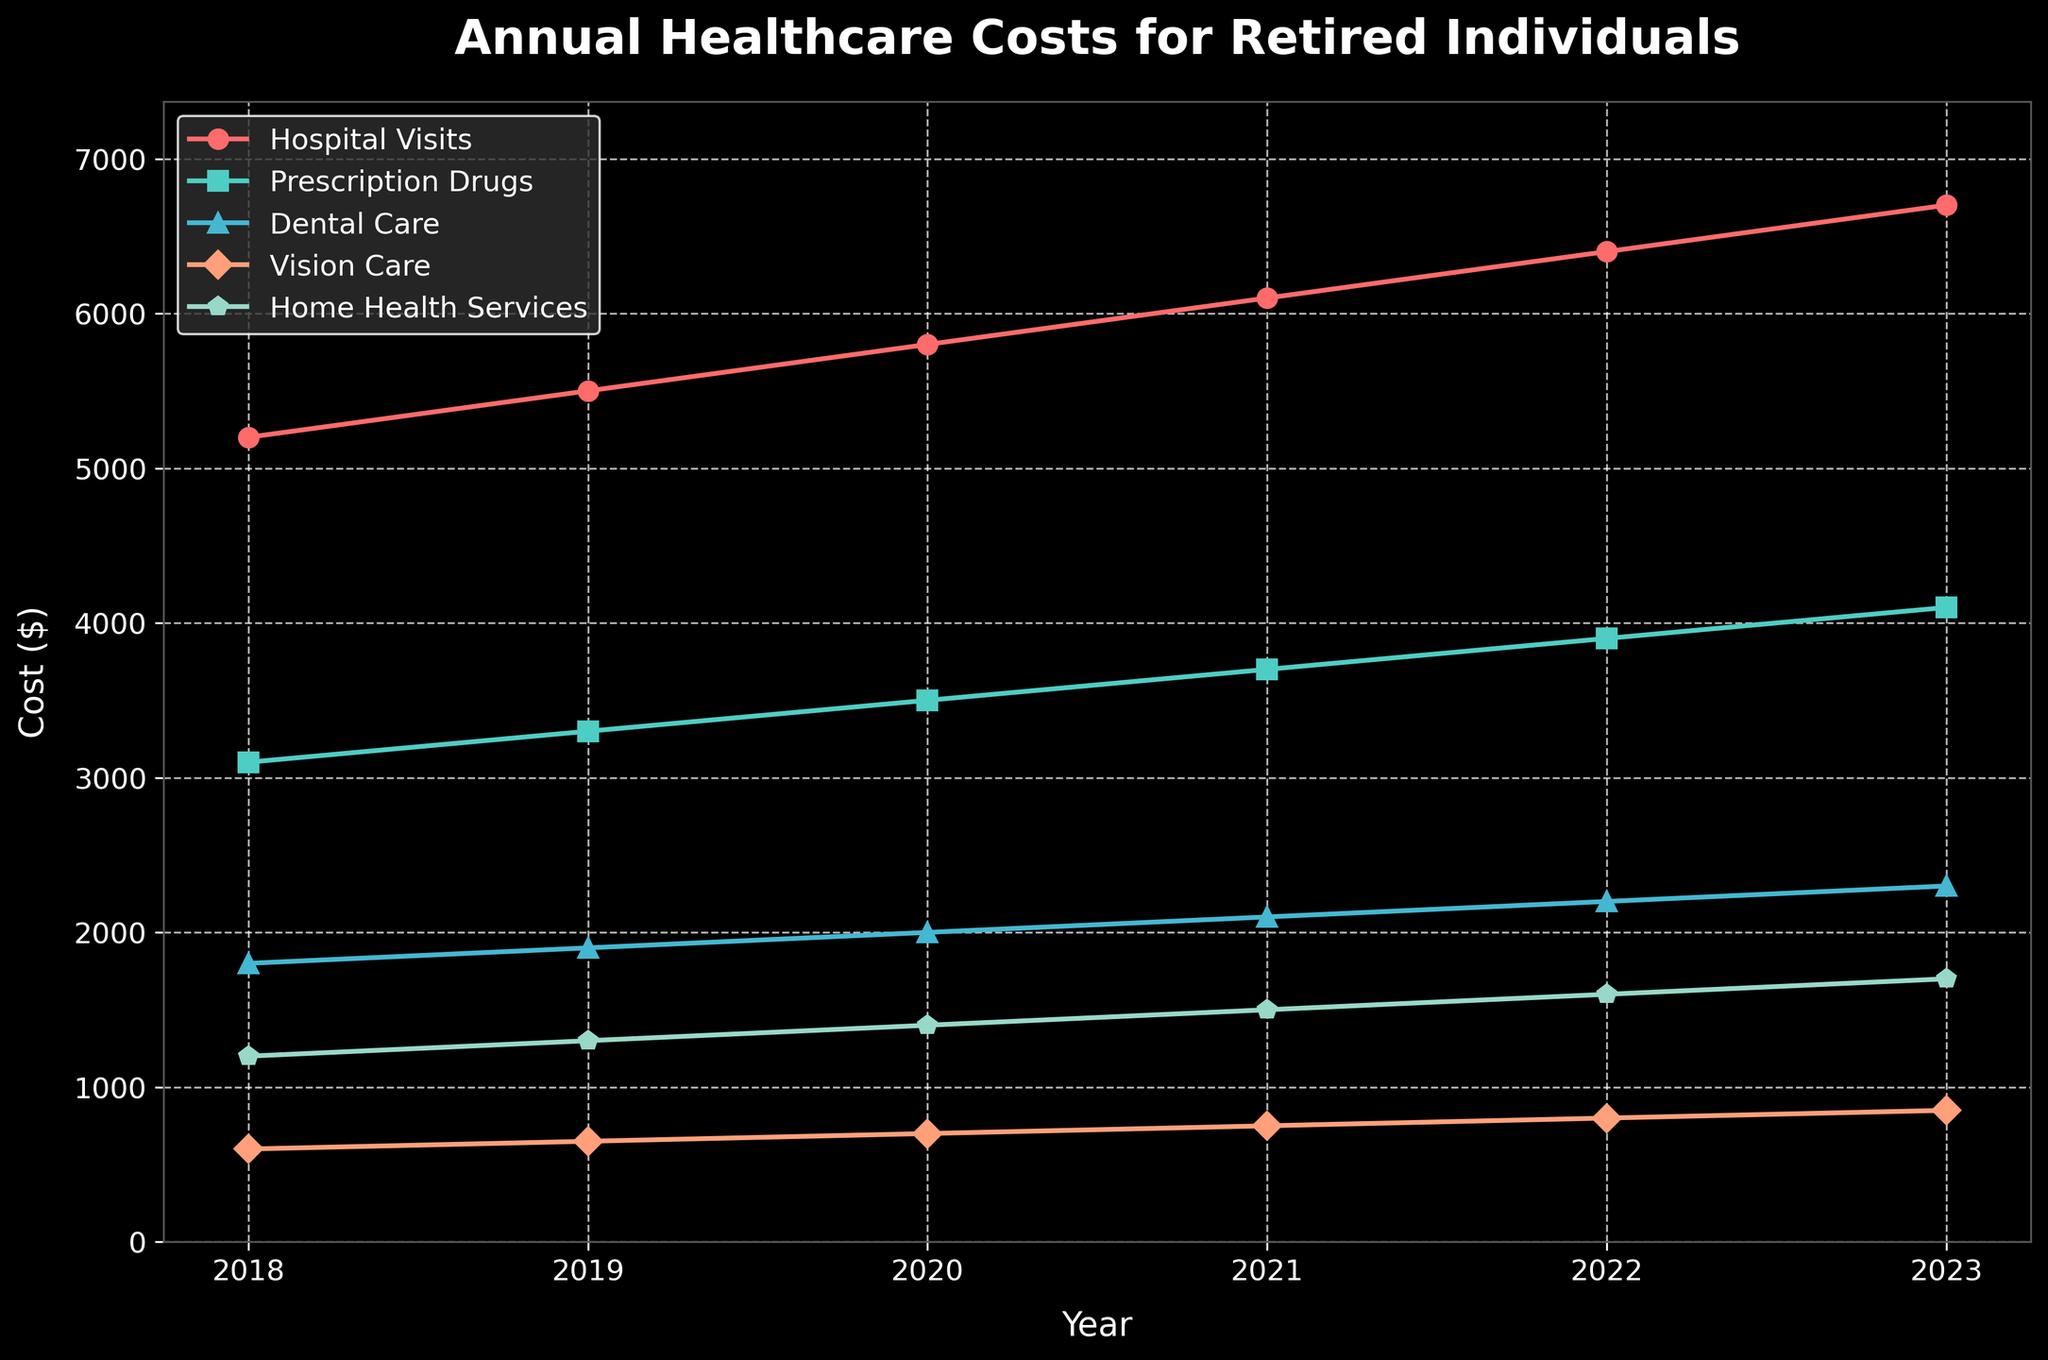What is the cost difference between Hospital Visits in 2023 and 2018? The cost of Hospital Visits in 2023 is $6700, and in 2018 it was $5200. The difference is $6700 - $5200 = $1500.
Answer: $1500 Which year shows the highest cost for Prescription Drugs? By looking at the Prescription Drugs line, the highest value is in 2023, where the cost is $4100.
Answer: 2023 What is the average annual cost of Vision Care from 2018 to 2023? Add the annual costs of Vision Care from 2018 to 2023: 600 + 650 + 700 + 750 + 800 + 850 = 4350. Divide by the number of years: 4350 / 6 = 725.
Answer: $725 Between Dental Care and Home Health Services, which had a higher increase in cost from 2018 to 2023? The increase for Dental Care from 2018 to 2023 is $2300 - $1800 = $500. The increase for Home Health Services from 2018 to 2023 is $1700 - $1200 = $500. Both categories had the same increase.
Answer: Both had the same increase In which year did the cost of Hospital Visits first exceed $6000? By following the Hospital Visits line, the cost first exceeds $6000 in 2021.
Answer: 2021 What is the total annual healthcare cost for all categories combined in 2020? Sum the costs of all categories for 2020: Hospital Visits $5800 + Prescription Drugs $3500 + Dental Care $2000 + Vision Care $700 + Home Health Services $1400 = $13400.
Answer: $13400 Which expense category showed a consistent annual increase every year between 2018 and 2023? By observing the lines, all categories (Hospital Visits, Prescription Drugs, Dental Care, Vision Care, Home Health Services) show consistent annual increases every year.
Answer: All categories How much more did Home Health Services cost in 2023 compared to Vision Care in 2023? Home Health Services in 2023 cost $1700, and Vision Care cost $850. The difference is $1700 - $850 = $850.
Answer: $850 